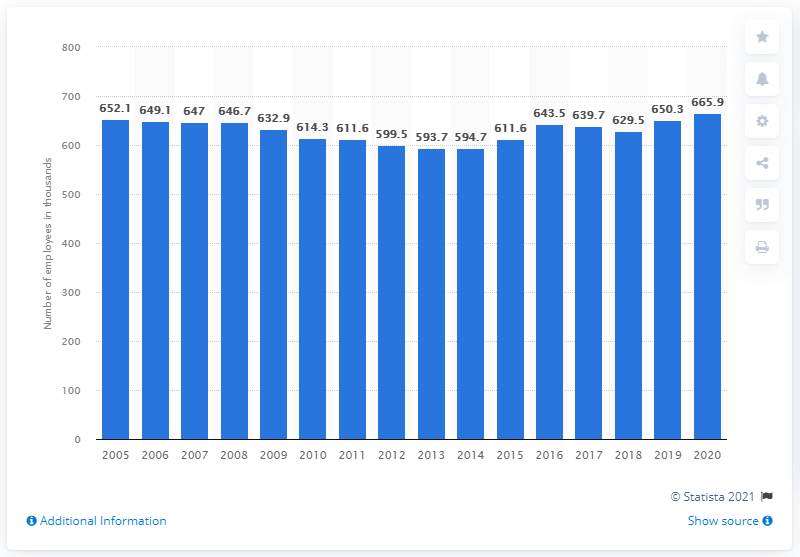Identify some key points in this picture. The property and casualty insurance industry began to decline in the year 2014. 